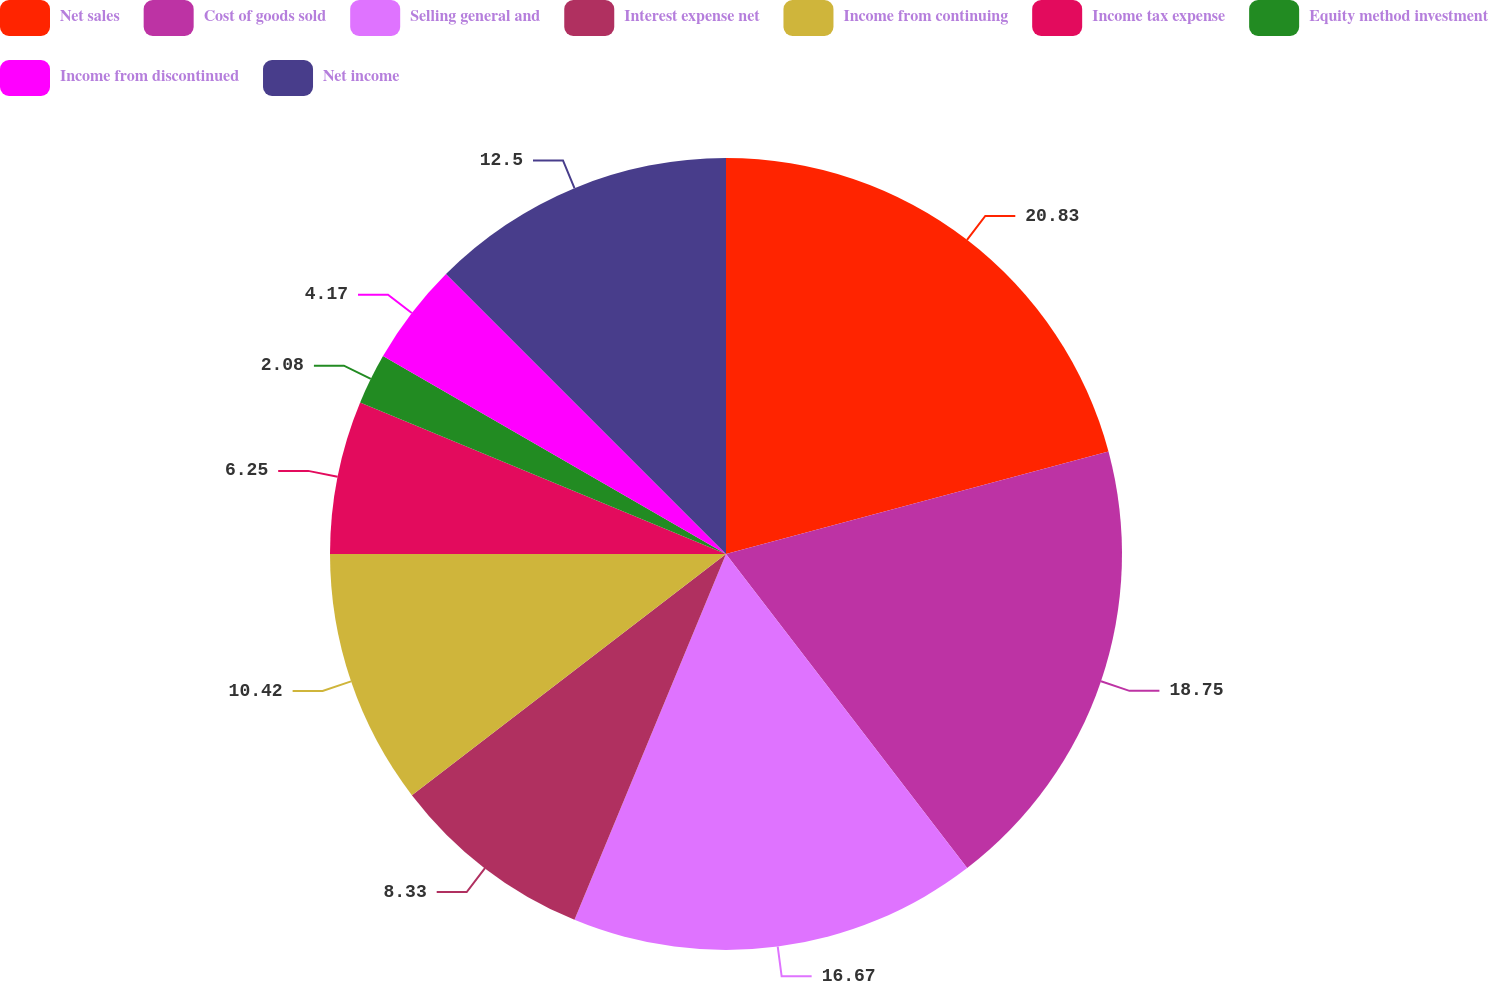Convert chart. <chart><loc_0><loc_0><loc_500><loc_500><pie_chart><fcel>Net sales<fcel>Cost of goods sold<fcel>Selling general and<fcel>Interest expense net<fcel>Income from continuing<fcel>Income tax expense<fcel>Equity method investment<fcel>Income from discontinued<fcel>Net income<nl><fcel>20.83%<fcel>18.75%<fcel>16.67%<fcel>8.33%<fcel>10.42%<fcel>6.25%<fcel>2.08%<fcel>4.17%<fcel>12.5%<nl></chart> 